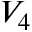Convert formula to latex. <formula><loc_0><loc_0><loc_500><loc_500>V _ { 4 }</formula> 